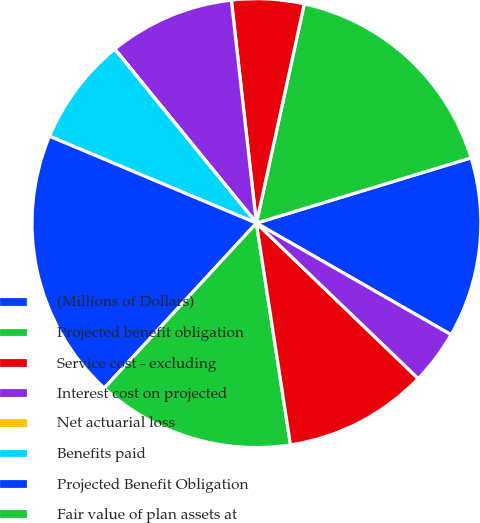<chart> <loc_0><loc_0><loc_500><loc_500><pie_chart><fcel>(Millions of Dollars)<fcel>Projected benefit obligation<fcel>Service cost - excluding<fcel>Interest cost on projected<fcel>Net actuarial loss<fcel>Benefits paid<fcel>Projected Benefit Obligation<fcel>Fair value of plan assets at<fcel>Actual return on plan assets<fcel>Employer contributions<nl><fcel>12.98%<fcel>16.88%<fcel>5.2%<fcel>9.09%<fcel>0.01%<fcel>7.79%<fcel>19.47%<fcel>14.28%<fcel>10.39%<fcel>3.9%<nl></chart> 